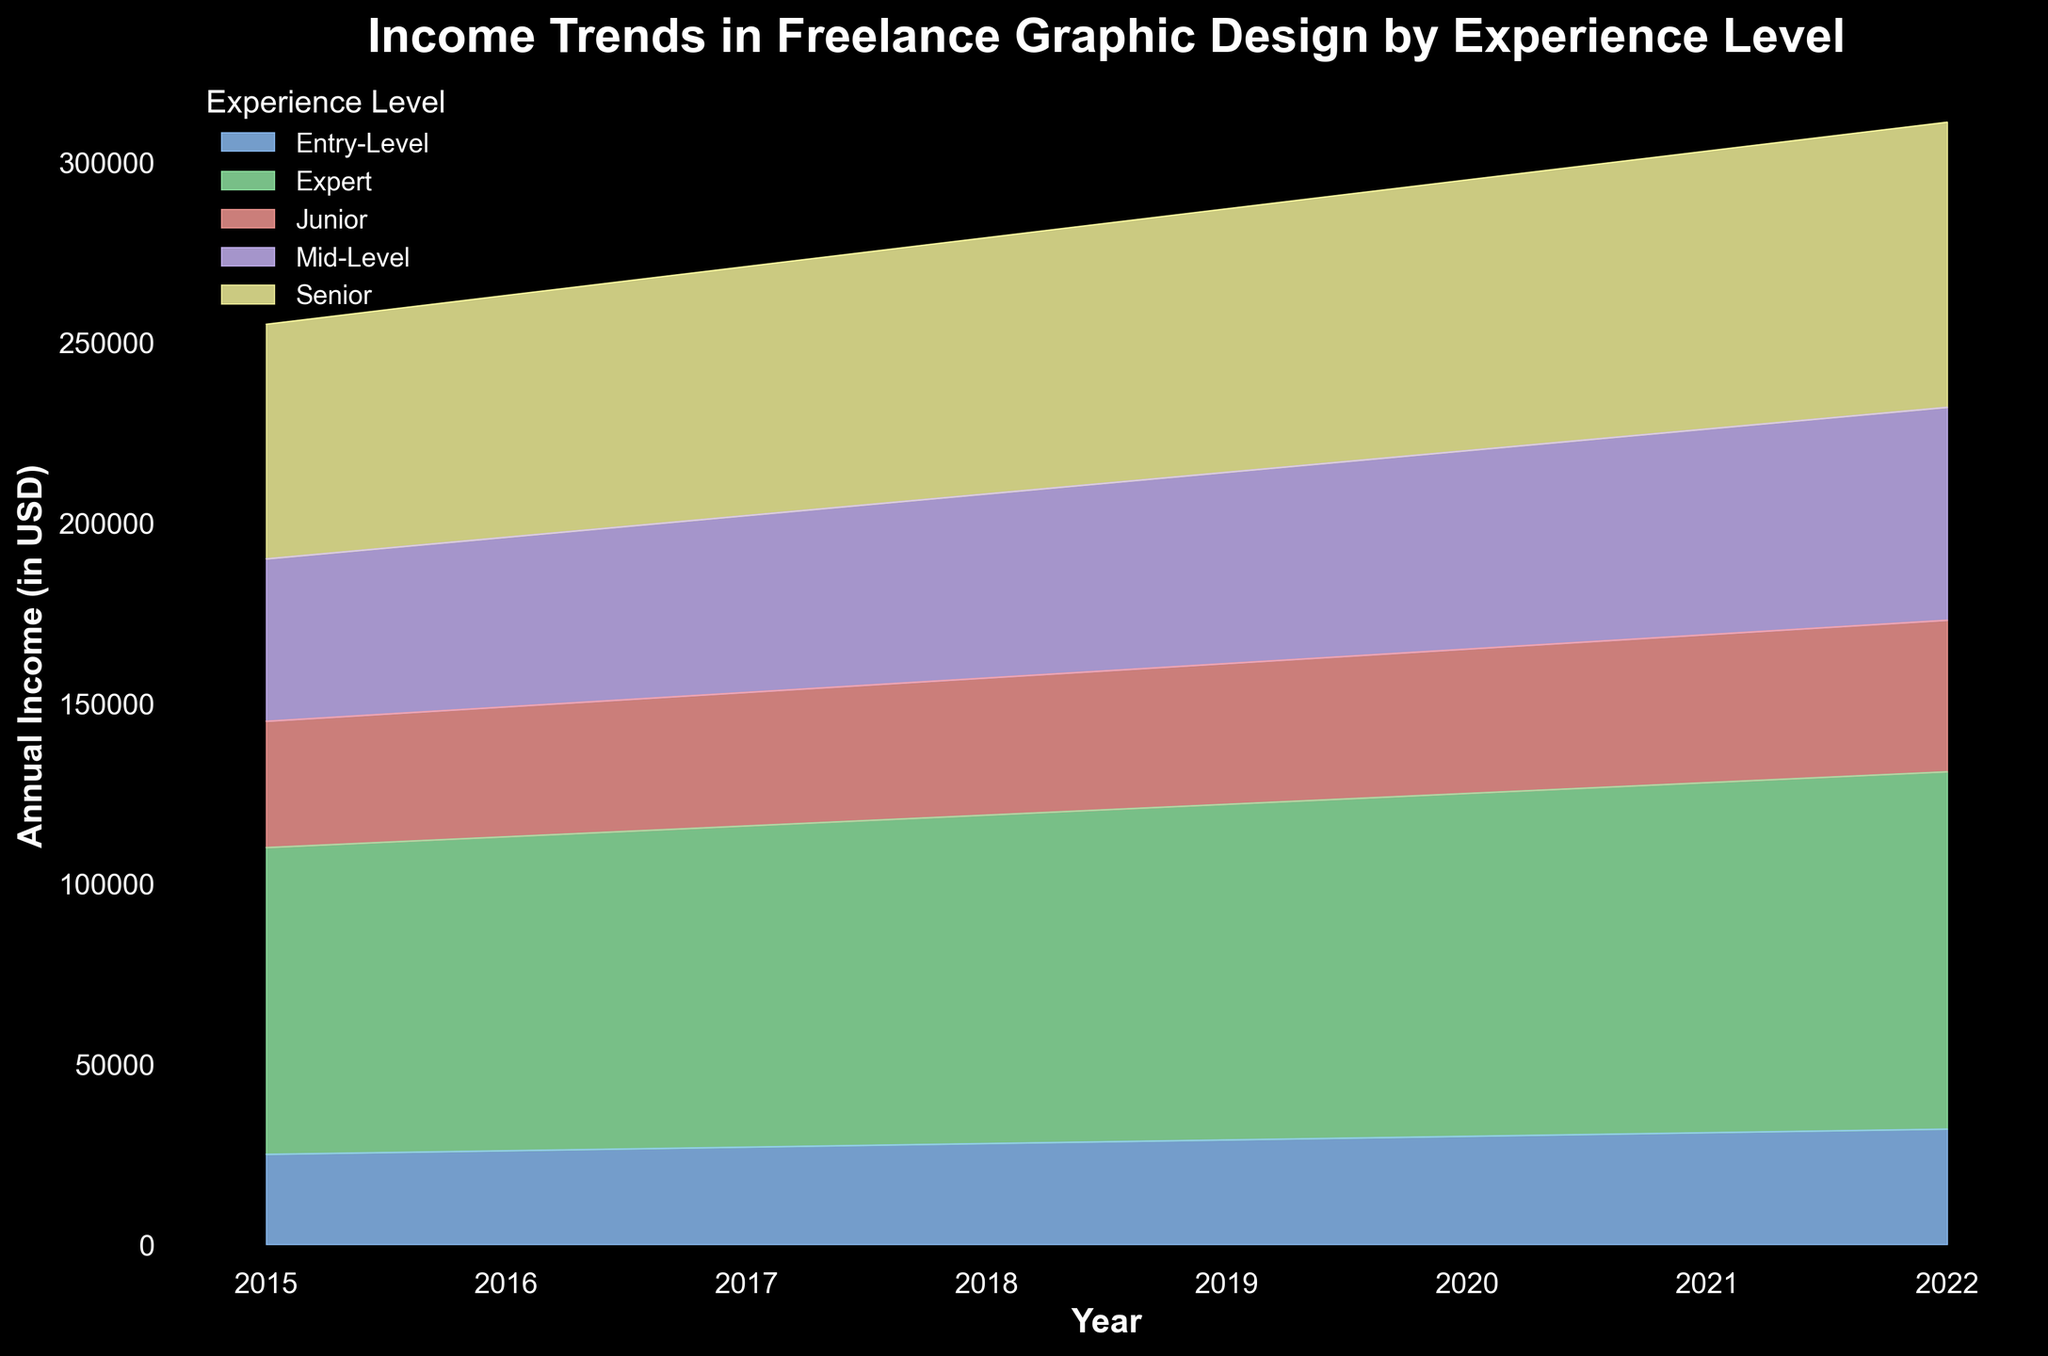How has the annual income for entry-level designers changed from 2015 to 2022? To figure this out, look at the area representing entry-level designers on the chart. In 2015, the income is around $25,000, and by 2022, it has increased to about $32,000. Calculate the difference to understand the change over time.
Answer: Increased by $7,000 Which experience level had the highest annual income in 2022? Refer to the topmost segment of the area chart for 2022. The Expert level is at the top, indicating the highest income for that year.
Answer: Expert What is the difference in annual income between mid-level and senior designers in 2019? Identify the areas representing mid-level and senior designers for the year 2019. The mid-level income is $53,000, and the senior income is $73,000. Subtract the mid-level income from the senior income to get the difference.
Answer: $20,000 Which experience levels saw a continuous increase in their annual income from 2015 to 2022? For continuous increase, all the points on the area chart for that experience level should be ascending. Entry-Level, Junior, Mid-Level, Senior, and Expert areas all show a continuous increase.
Answer: All levels What is the average income for junior designers between 2017 and 2022? Sum the incomes for Junior designers from 2017 to 2022 and divide by the number of years. Incomes are $37,000, $38,000, $39,000, $40,000, $41,000, and $42,000. Sum: $237,000. Divide by 6 years for the average.
Answer: $39,500 By how much did the income for Expert designers increase from 2015 to 2018? Check the area chart for Expert designers from 2015 to 2018. In 2015, income is $85,000, and in 2018, it is $91,000. Subtract the 2015 income from the 2018 income.
Answer: $6,000 Which two experience levels are the closest in income in 2020? Compare the heights of the areas for each experience level in 2020. Junior ($40,000) and entry-level ($30,000) are one step apart, but Mid-Level ($55,000) and Senior ($75,000) are closer to each other in difference rather. Mid-Level and Senior income differences are fewer.
Answer: Mid-Level and Senior What is the overall trend for annual income for all experience levels from 2015 to 2022? Look for the general direction of the area chart. All experience levels show a continuous increase in income, indicating an overall upward trend.
Answer: Upward trend Does any experience level's income decrease at any point between 2015 and 2022? Visual inspection of the chart shows no segment's area decreasing at any point; all income levels consistently increase.
Answer: No What is the sum of the annual incomes for Entry-Level designers from 2015 to 2022? Sum the annual incomes for Entry-Level designers from each year: $25,000 + $26,000 + $27,000 + $28,000 + $29,000 + $30,000 + $31,000 + $32,000.
Answer: $228,000 